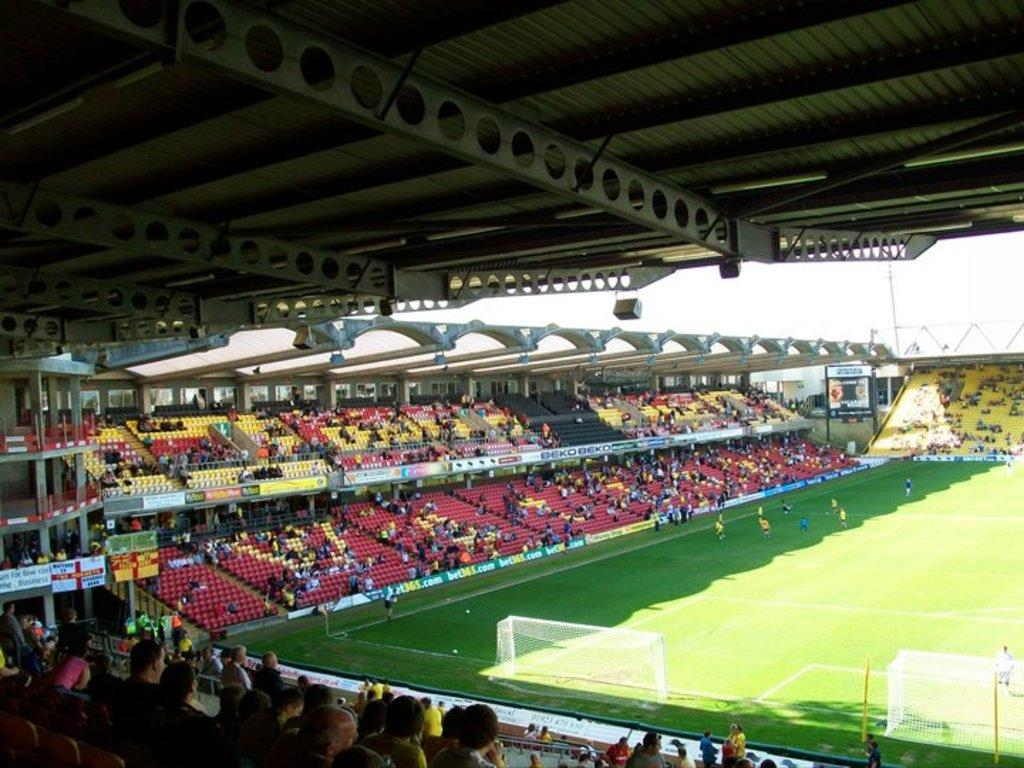What type of venue is depicted in the image? The image shows an inside view of a stadium. What can be seen inside the stadium? There is an audience, a ground, a sports net, and players inside the stadium. What might the players be doing in the stadium? The players might be participating in a sports event or practicing. What message does the audience give to the players as they leave the stadium? The image does not show the players leaving the stadium, nor does it depict any communication between the audience and the players. 